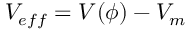Convert formula to latex. <formula><loc_0><loc_0><loc_500><loc_500>V _ { e f f } = V ( \phi ) - V _ { m }</formula> 